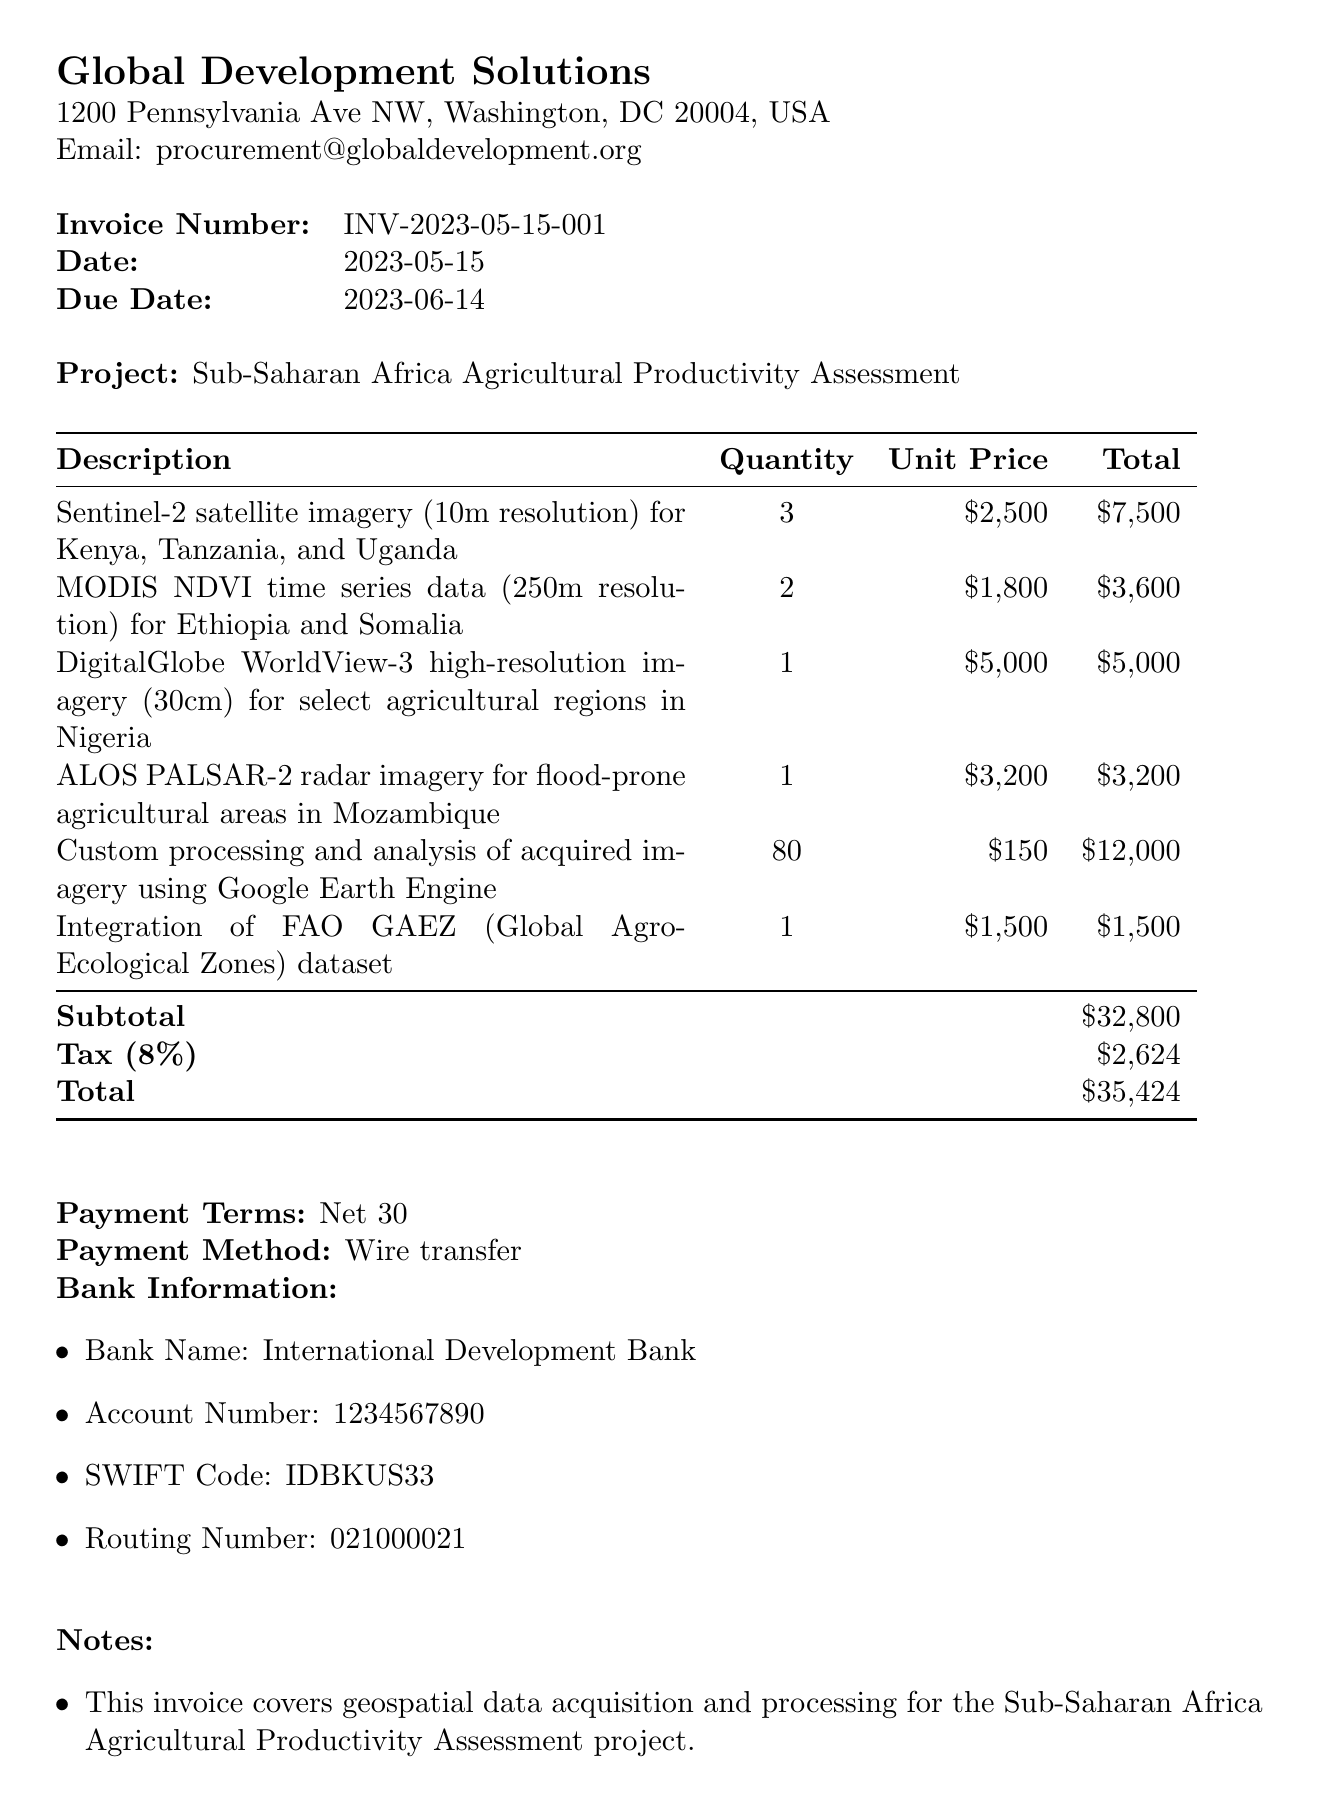What is the vendor's name? The document lists the vendor's name at the bottom, which is GeoSpatial Solutions Inc.
Answer: GeoSpatial Solutions Inc What is the total amount due? The total amount is provided in the summary section of the document, which indicates that the total due is $35,424.
Answer: $35,424 What is the due date of the invoice? The due date of the invoice is specified clearly in the document as June 14, 2023.
Answer: June 14, 2023 How many Sentinel-2 satellite imagery products were ordered? The quantity of Sentinel-2 satellite imagery is stated in the itemized list, showing that 3 were ordered.
Answer: 3 What is the unit price of the DigitalGlobe WorldView-3 high-resolution imagery? In the itemized list, the unit price for the DigitalGlobe WorldView-3 imagery is mentioned as $5,000.
Answer: $5,000 What is the tax rate applied to the invoice? The tax rate is explicitly stated in the document as 8%.
Answer: 8% Which payment method is specified for this invoice? The payment method is indicated in the document, which states that the payment should be made via wire transfer.
Answer: Wire transfer What is the main purpose of the satellite data? The notes section explains that the satellite data will be used for analyzing crop yields, land use changes, and agricultural expansion areas.
Answer: Analyzing crop yields, land use changes, and agricultural expansion 